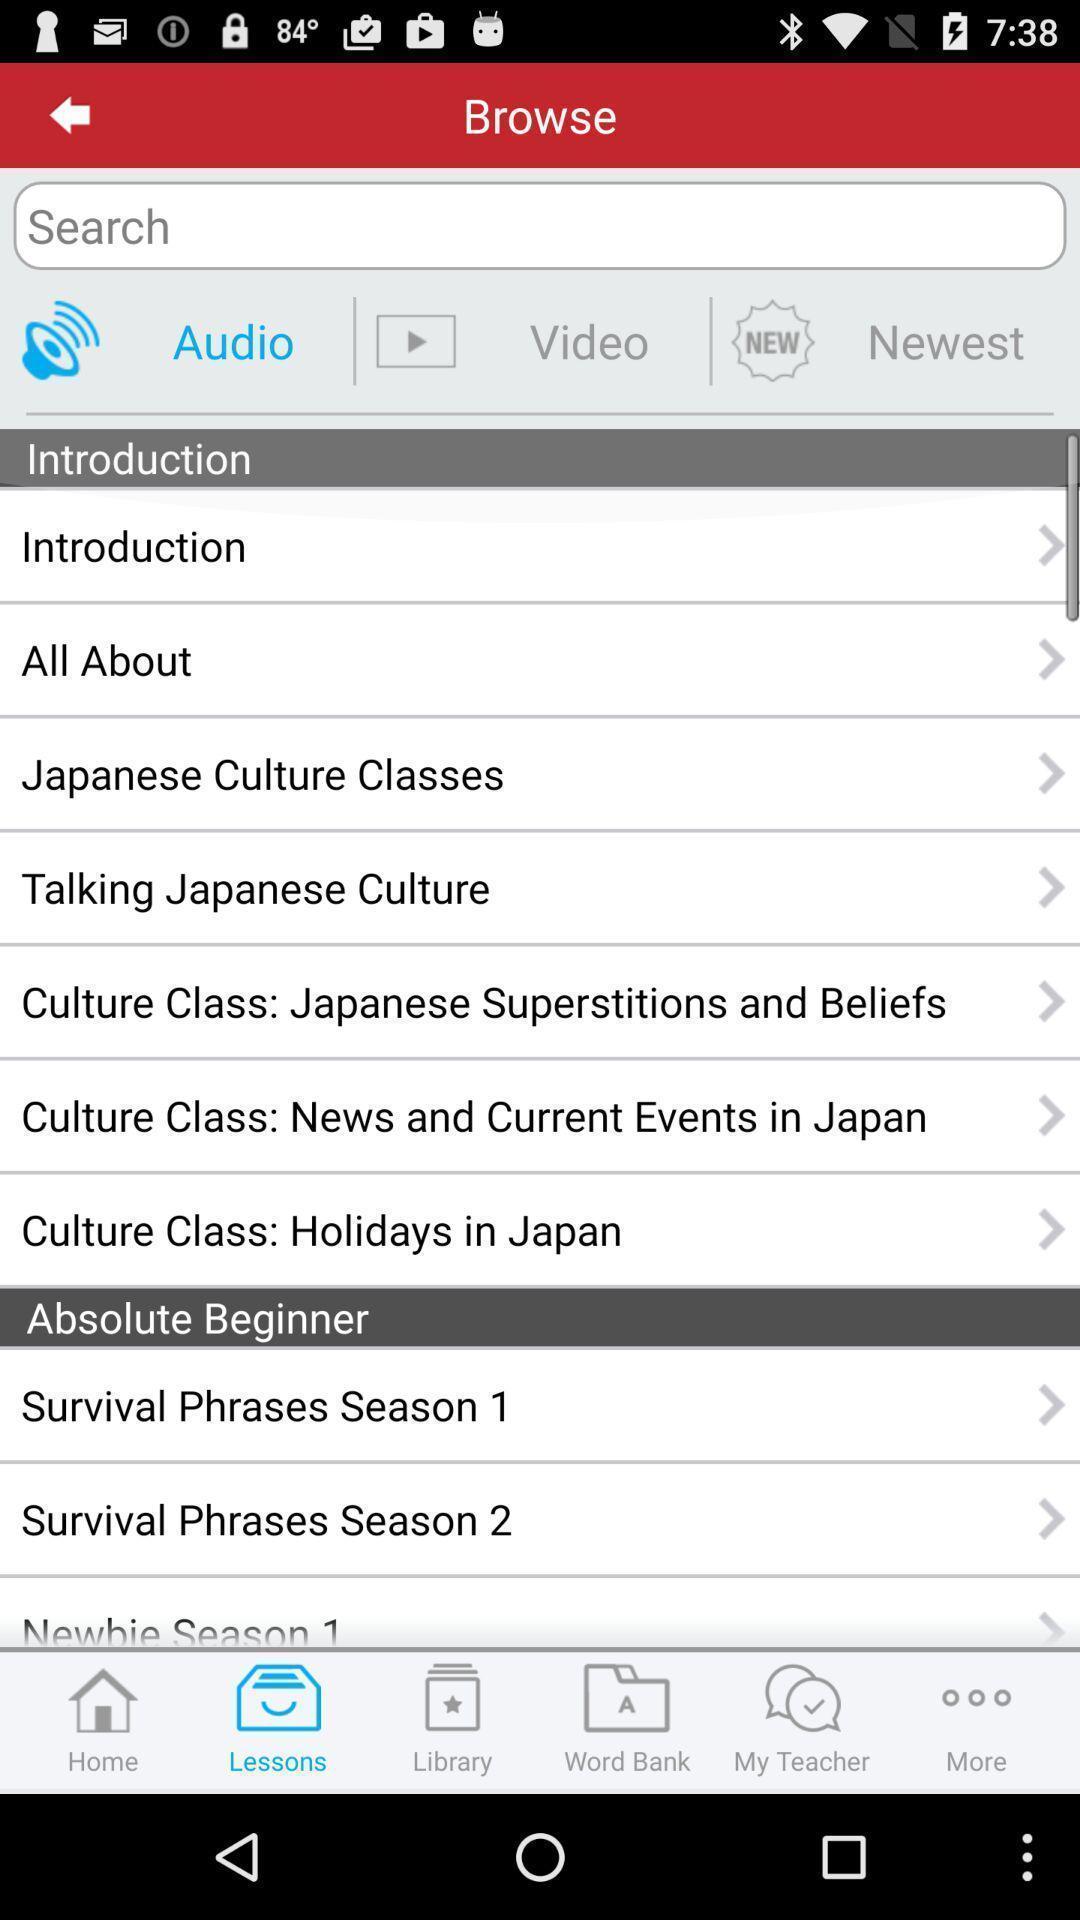Tell me what you see in this picture. Page displaying to browse of an learning application. 